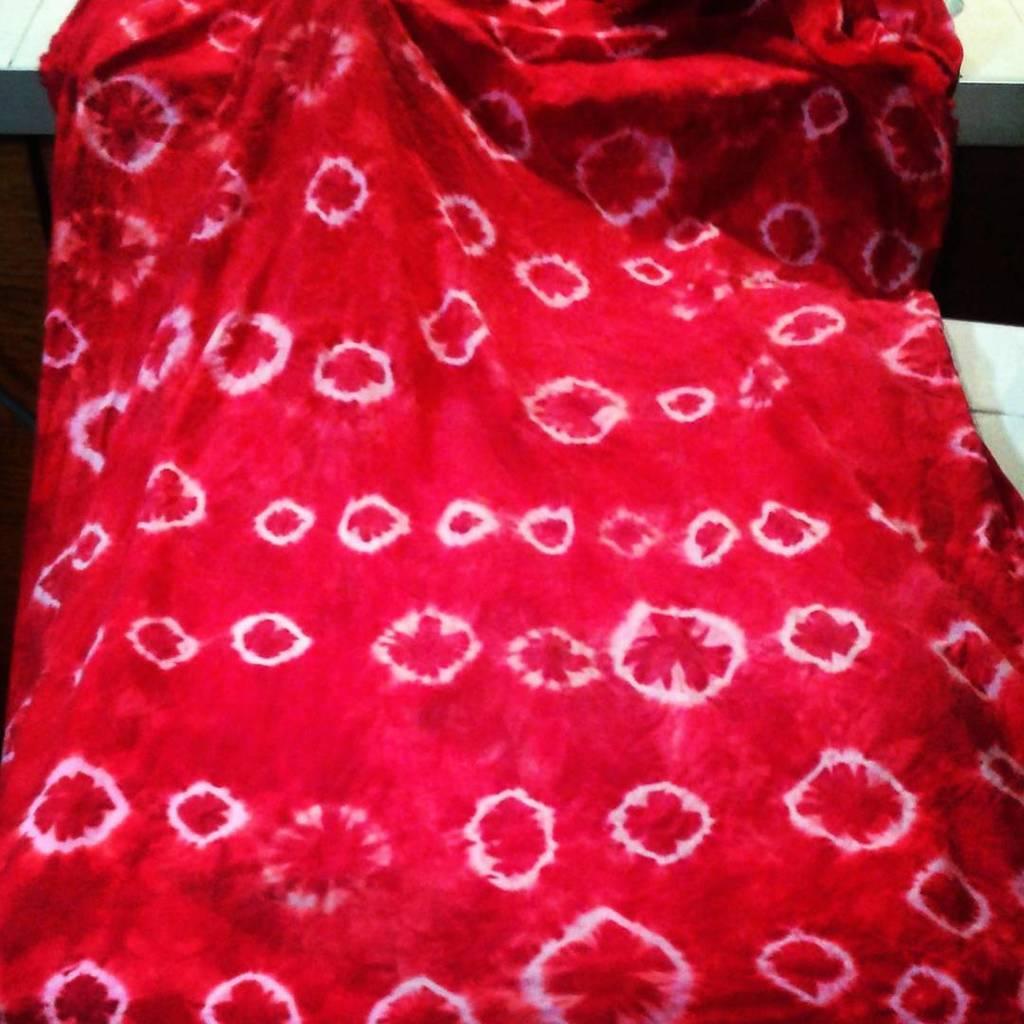How would you summarize this image in a sentence or two? In the picture we can observe a red coloured blanket. 